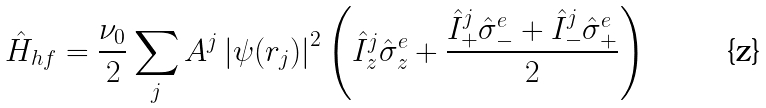Convert formula to latex. <formula><loc_0><loc_0><loc_500><loc_500>\hat { H } _ { h f } = \frac { \nu _ { 0 } } { 2 } \sum _ { j } A ^ { j } \left | \psi ( r _ { j } ) \right | ^ { 2 } \left ( \hat { I } _ { z } ^ { j } \hat { \sigma } ^ { e } _ { z } + \frac { \hat { I } _ { + } ^ { j } \hat { \sigma } ^ { e } _ { - } + \hat { I } _ { - } ^ { j } \hat { \sigma } ^ { e } _ { + } } { 2 } \right )</formula> 